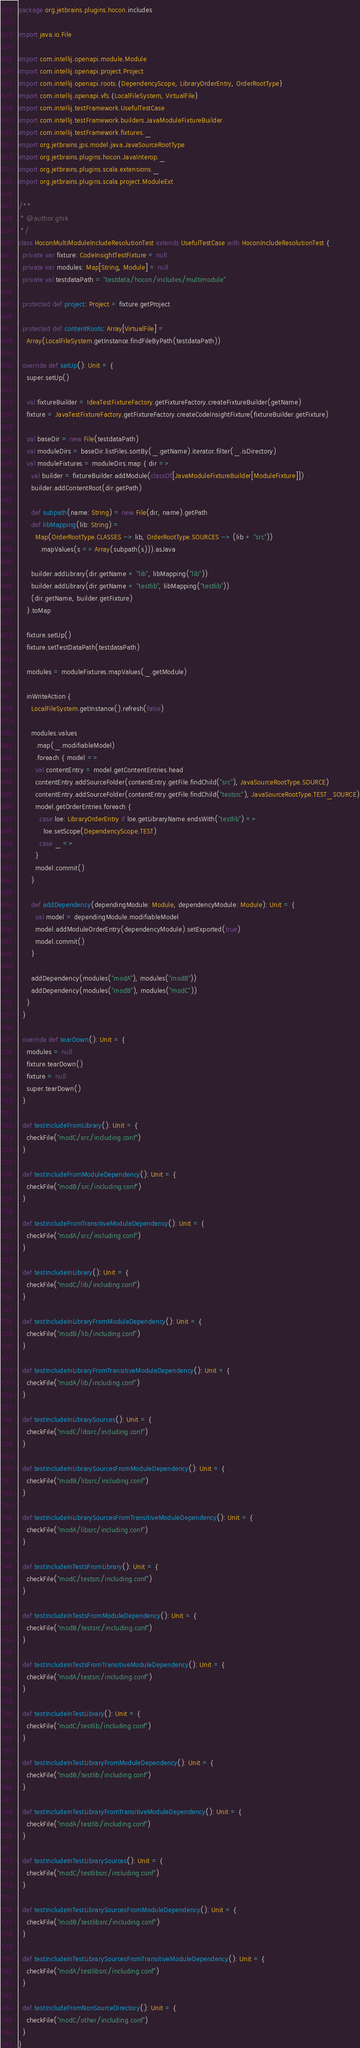Convert code to text. <code><loc_0><loc_0><loc_500><loc_500><_Scala_>package org.jetbrains.plugins.hocon.includes

import java.io.File

import com.intellij.openapi.module.Module
import com.intellij.openapi.project.Project
import com.intellij.openapi.roots.{DependencyScope, LibraryOrderEntry, OrderRootType}
import com.intellij.openapi.vfs.{LocalFileSystem, VirtualFile}
import com.intellij.testFramework.UsefulTestCase
import com.intellij.testFramework.builders.JavaModuleFixtureBuilder
import com.intellij.testFramework.fixtures._
import org.jetbrains.jps.model.java.JavaSourceRootType
import org.jetbrains.plugins.hocon.JavaInterop._
import org.jetbrains.plugins.scala.extensions._
import org.jetbrains.plugins.scala.project.ModuleExt

/**
 * @author ghik
 */
class HoconMultiModuleIncludeResolutionTest extends UsefulTestCase with HoconIncludeResolutionTest {
  private var fixture: CodeInsightTestFixture = null
  private var modules: Map[String, Module] = null
  private val testdataPath = "testdata/hocon/includes/multimodule"

  protected def project: Project = fixture.getProject

  protected def contentRoots: Array[VirtualFile] =
    Array(LocalFileSystem.getInstance.findFileByPath(testdataPath))

  override def setUp(): Unit = {
    super.setUp()

    val fixtureBuilder = IdeaTestFixtureFactory.getFixtureFactory.createFixtureBuilder(getName)
    fixture = JavaTestFixtureFactory.getFixtureFactory.createCodeInsightFixture(fixtureBuilder.getFixture)

    val baseDir = new File(testdataPath)
    val moduleDirs = baseDir.listFiles.sortBy(_.getName).iterator.filter(_.isDirectory)
    val moduleFixtures = moduleDirs.map { dir =>
      val builder = fixtureBuilder.addModule(classOf[JavaModuleFixtureBuilder[ModuleFixture]])
      builder.addContentRoot(dir.getPath)

      def subpath(name: String) = new File(dir, name).getPath
      def libMapping(lib: String) =
        Map(OrderRootType.CLASSES -> lib, OrderRootType.SOURCES -> (lib + "src"))
          .mapValues(s => Array(subpath(s))).asJava

      builder.addLibrary(dir.getName + "lib", libMapping("lib"))
      builder.addLibrary(dir.getName + "testlib", libMapping("testlib"))
      (dir.getName, builder.getFixture)
    }.toMap

    fixture.setUp()
    fixture.setTestDataPath(testdataPath)

    modules = moduleFixtures.mapValues(_.getModule)

    inWriteAction {
      LocalFileSystem.getInstance().refresh(false)

      modules.values
        .map(_.modifiableModel)
        .foreach { model =>
        val contentEntry = model.getContentEntries.head
        contentEntry.addSourceFolder(contentEntry.getFile.findChild("src"), JavaSourceRootType.SOURCE)
        contentEntry.addSourceFolder(contentEntry.getFile.findChild("testsrc"), JavaSourceRootType.TEST_SOURCE)
        model.getOrderEntries.foreach {
          case loe: LibraryOrderEntry if loe.getLibraryName.endsWith("testlib") =>
            loe.setScope(DependencyScope.TEST)
          case _ =>
        }
        model.commit()
      }

      def addDependency(dependingModule: Module, dependencyModule: Module): Unit = {
        val model = dependingModule.modifiableModel
        model.addModuleOrderEntry(dependencyModule).setExported(true)
        model.commit()
      }

      addDependency(modules("modA"), modules("modB"))
      addDependency(modules("modB"), modules("modC"))
    }
  }

  override def tearDown(): Unit = {
    modules = null
    fixture.tearDown()
    fixture = null
    super.tearDown()
  }

  def testIncludeFromLibrary(): Unit = {
    checkFile("modC/src/including.conf")
  }

  def testIncludeFromModuleDependency(): Unit = {
    checkFile("modB/src/including.conf")
  }

  def testIncludeFromTransitiveModuleDependency(): Unit = {
    checkFile("modA/src/including.conf")
  }

  def testIncludeInLibrary(): Unit = {
    checkFile("modC/lib/including.conf")
  }

  def testIncludeInLibraryFromModuleDependency(): Unit = {
    checkFile("modB/lib/including.conf")
  }

  def testIncludeInLibraryFromTransitiveModuleDependency(): Unit = {
    checkFile("modA/lib/including.conf")
  }

  def testIncludeInLibrarySources(): Unit = {
    checkFile("modC/libsrc/including.conf")
  }

  def testIncludeInLibrarySourcesFromModuleDependency(): Unit = {
    checkFile("modB/libsrc/including.conf")
  }

  def testIncludeInLibrarySourcesFromTransitiveModuleDependency(): Unit = {
    checkFile("modA/libsrc/including.conf")
  }

  def testIncludeInTestsFromLibrary(): Unit = {
    checkFile("modC/testsrc/including.conf")
  }

  def testIncludeInTestsFromModuleDependency(): Unit = {
    checkFile("modB/testsrc/including.conf")
  }

  def testIncludeInTestsFromTransitiveModuleDependency(): Unit = {
    checkFile("modA/testsrc/including.conf")
  }

  def testIncludeInTestLibrary(): Unit = {
    checkFile("modC/testlib/including.conf")
  }

  def testIncludeInTestLibraryFromModuleDependency(): Unit = {
    checkFile("modB/testlib/including.conf")
  }

  def testIncludeInTestLibraryFromTransitiveModuleDependency(): Unit = {
    checkFile("modA/testlib/including.conf")
  }

  def testIncludeInTestLibrarySources(): Unit = {
    checkFile("modC/testlibsrc/including.conf")
  }

  def testIncludeInTestLibrarySourcesFromModuleDependency(): Unit = {
    checkFile("modB/testlibsrc/including.conf")
  }

  def testIncludeInTestLibrarySourcesFromTransitiveModuleDependency(): Unit = {
    checkFile("modA/testlibsrc/including.conf")
  }

  def testIncludeFromNonSourceDirectory(): Unit = {
    checkFile("modC/other/including.conf")
  }
}
</code> 